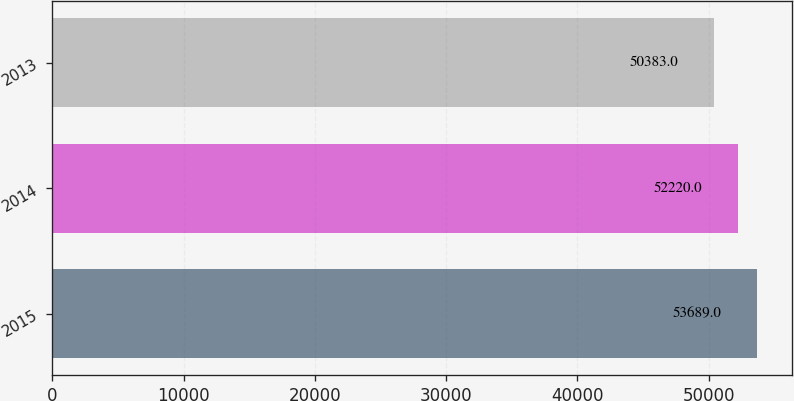Convert chart. <chart><loc_0><loc_0><loc_500><loc_500><bar_chart><fcel>2015<fcel>2014<fcel>2013<nl><fcel>53689<fcel>52220<fcel>50383<nl></chart> 